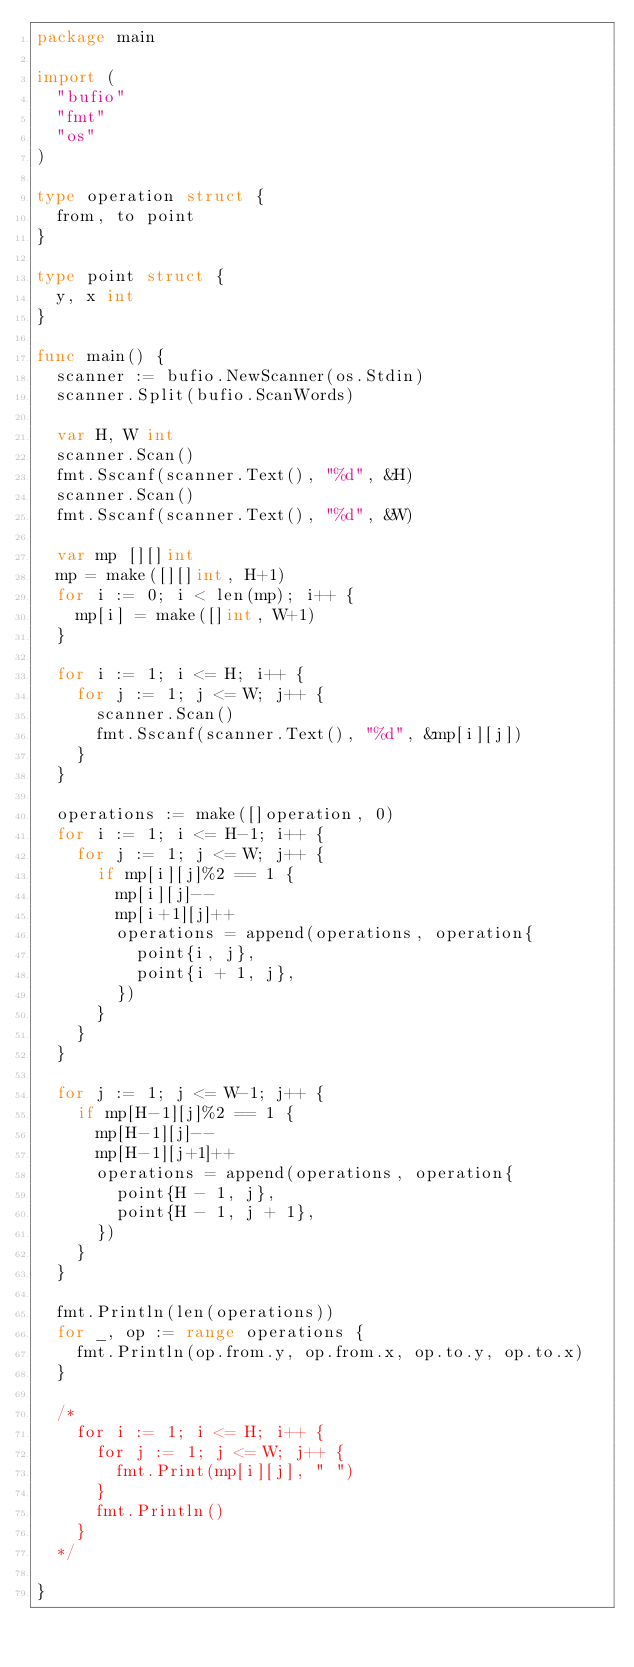Convert code to text. <code><loc_0><loc_0><loc_500><loc_500><_Go_>package main

import (
	"bufio"
	"fmt"
	"os"
)

type operation struct {
	from, to point
}

type point struct {
	y, x int
}

func main() {
	scanner := bufio.NewScanner(os.Stdin)
	scanner.Split(bufio.ScanWords)

	var H, W int
	scanner.Scan()
	fmt.Sscanf(scanner.Text(), "%d", &H)
	scanner.Scan()
	fmt.Sscanf(scanner.Text(), "%d", &W)

	var mp [][]int
	mp = make([][]int, H+1)
	for i := 0; i < len(mp); i++ {
		mp[i] = make([]int, W+1)
	}

	for i := 1; i <= H; i++ {
		for j := 1; j <= W; j++ {
			scanner.Scan()
			fmt.Sscanf(scanner.Text(), "%d", &mp[i][j])
		}
	}

	operations := make([]operation, 0)
	for i := 1; i <= H-1; i++ {
		for j := 1; j <= W; j++ {
			if mp[i][j]%2 == 1 {
				mp[i][j]--
				mp[i+1][j]++
				operations = append(operations, operation{
					point{i, j},
					point{i + 1, j},
				})
			}
		}
	}

	for j := 1; j <= W-1; j++ {
		if mp[H-1][j]%2 == 1 {
			mp[H-1][j]--
			mp[H-1][j+1]++
			operations = append(operations, operation{
				point{H - 1, j},
				point{H - 1, j + 1},
			})
		}
	}

	fmt.Println(len(operations))
	for _, op := range operations {
		fmt.Println(op.from.y, op.from.x, op.to.y, op.to.x)
	}

	/*
		for i := 1; i <= H; i++ {
			for j := 1; j <= W; j++ {
				fmt.Print(mp[i][j], " ")
			}
			fmt.Println()
		}
	*/

}
</code> 